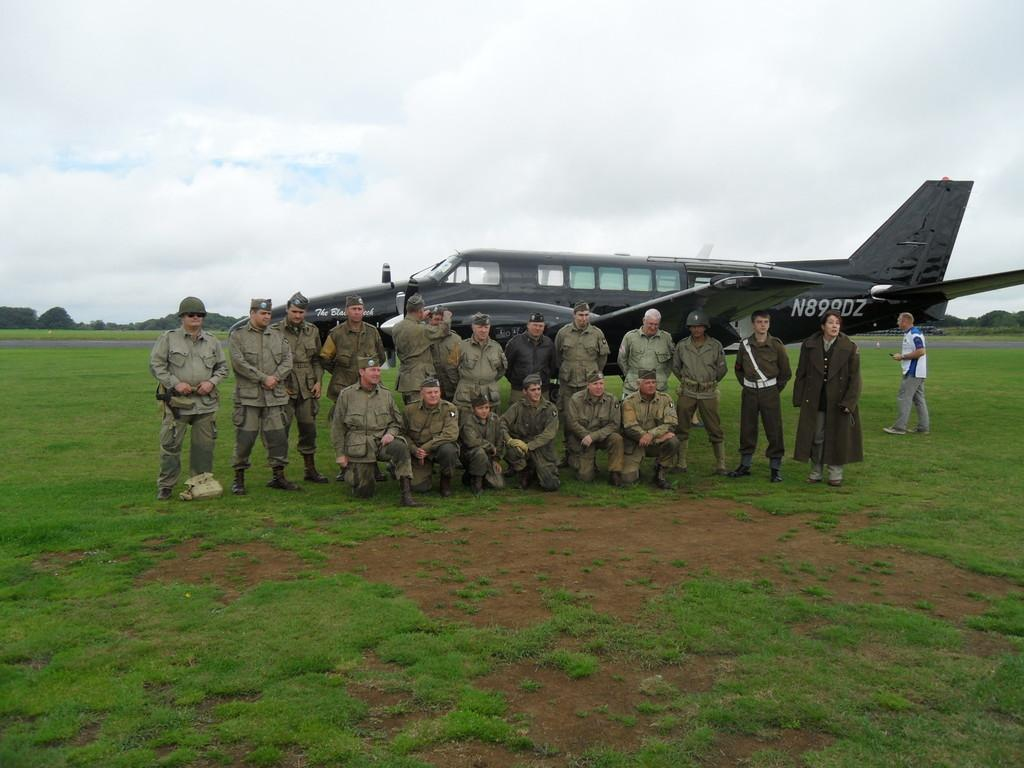<image>
Write a terse but informative summary of the picture. The identification numbers on the black aircraft are N899DZ. 